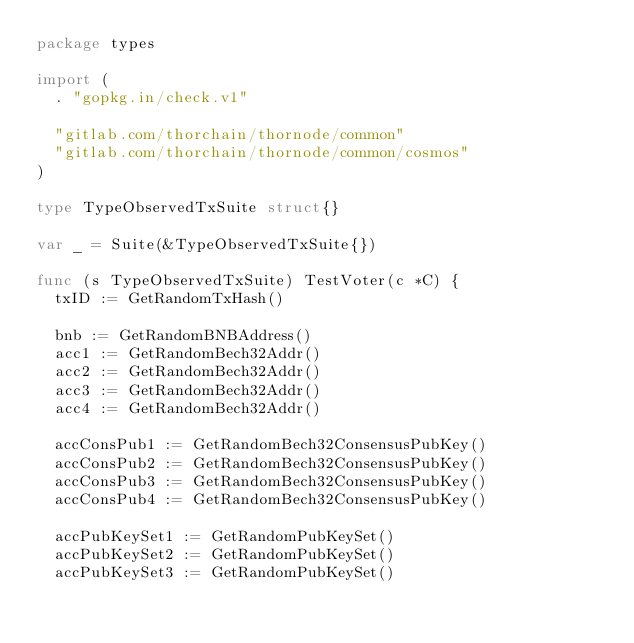Convert code to text. <code><loc_0><loc_0><loc_500><loc_500><_Go_>package types

import (
	. "gopkg.in/check.v1"

	"gitlab.com/thorchain/thornode/common"
	"gitlab.com/thorchain/thornode/common/cosmos"
)

type TypeObservedTxSuite struct{}

var _ = Suite(&TypeObservedTxSuite{})

func (s TypeObservedTxSuite) TestVoter(c *C) {
	txID := GetRandomTxHash()

	bnb := GetRandomBNBAddress()
	acc1 := GetRandomBech32Addr()
	acc2 := GetRandomBech32Addr()
	acc3 := GetRandomBech32Addr()
	acc4 := GetRandomBech32Addr()

	accConsPub1 := GetRandomBech32ConsensusPubKey()
	accConsPub2 := GetRandomBech32ConsensusPubKey()
	accConsPub3 := GetRandomBech32ConsensusPubKey()
	accConsPub4 := GetRandomBech32ConsensusPubKey()

	accPubKeySet1 := GetRandomPubKeySet()
	accPubKeySet2 := GetRandomPubKeySet()
	accPubKeySet3 := GetRandomPubKeySet()</code> 